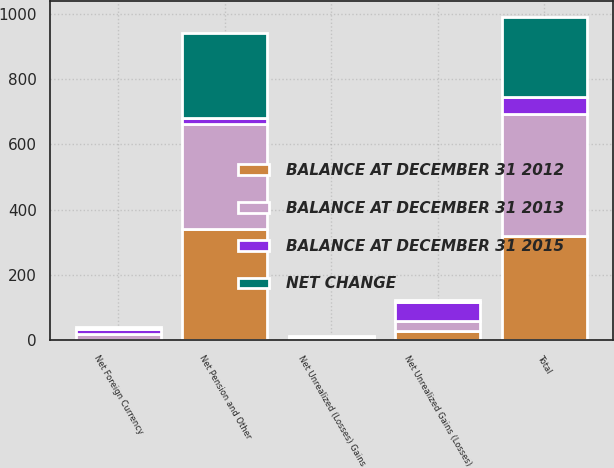Convert chart to OTSL. <chart><loc_0><loc_0><loc_500><loc_500><stacked_bar_chart><ecel><fcel>Net Unrealized Gains (Losses)<fcel>Net Unrealized (Losses) Gains<fcel>Net Foreign Currency<fcel>Net Pension and Other<fcel>Total<nl><fcel>BALANCE AT DECEMBER 31 2013<fcel>31<fcel>3<fcel>17.6<fcel>321.1<fcel>372.7<nl><fcel>BALANCE AT DECEMBER 31 2015<fcel>58.6<fcel>1.7<fcel>15.9<fcel>19.8<fcel>53<nl><fcel>BALANCE AT DECEMBER 31 2012<fcel>27.6<fcel>4.7<fcel>1.7<fcel>340.9<fcel>319.7<nl><fcel>NET CHANGE<fcel>6<fcel>2.9<fcel>7.1<fcel>260.3<fcel>244.3<nl></chart> 